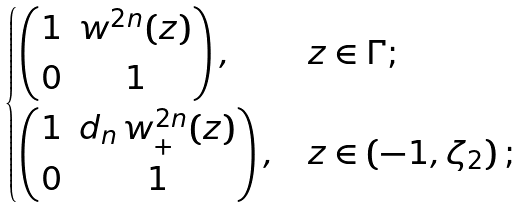Convert formula to latex. <formula><loc_0><loc_0><loc_500><loc_500>\begin{cases} \begin{pmatrix} 1 & w ^ { 2 n } ( z ) \\ 0 & 1 \\ \end{pmatrix} , & z \in \Gamma ; \\ \begin{pmatrix} 1 & d _ { n } \, w ^ { 2 n } _ { + } ( z ) \\ 0 & 1 \\ \end{pmatrix} , & z \in ( - 1 , \zeta _ { 2 } ) \, ; \end{cases}</formula> 